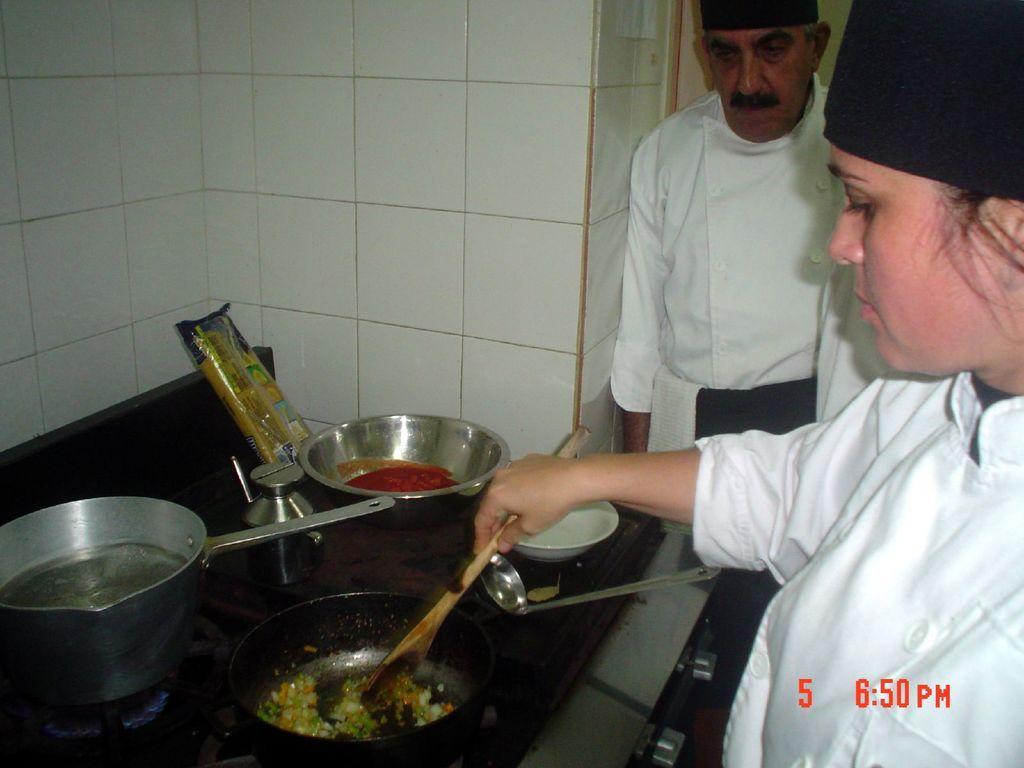Please provide a concise description of this image. In the picture we can see a woman chef cooking something holding a spoon near the desk and on it we can see some bowls on the stove and beside it we can see a man standing and watching it. 